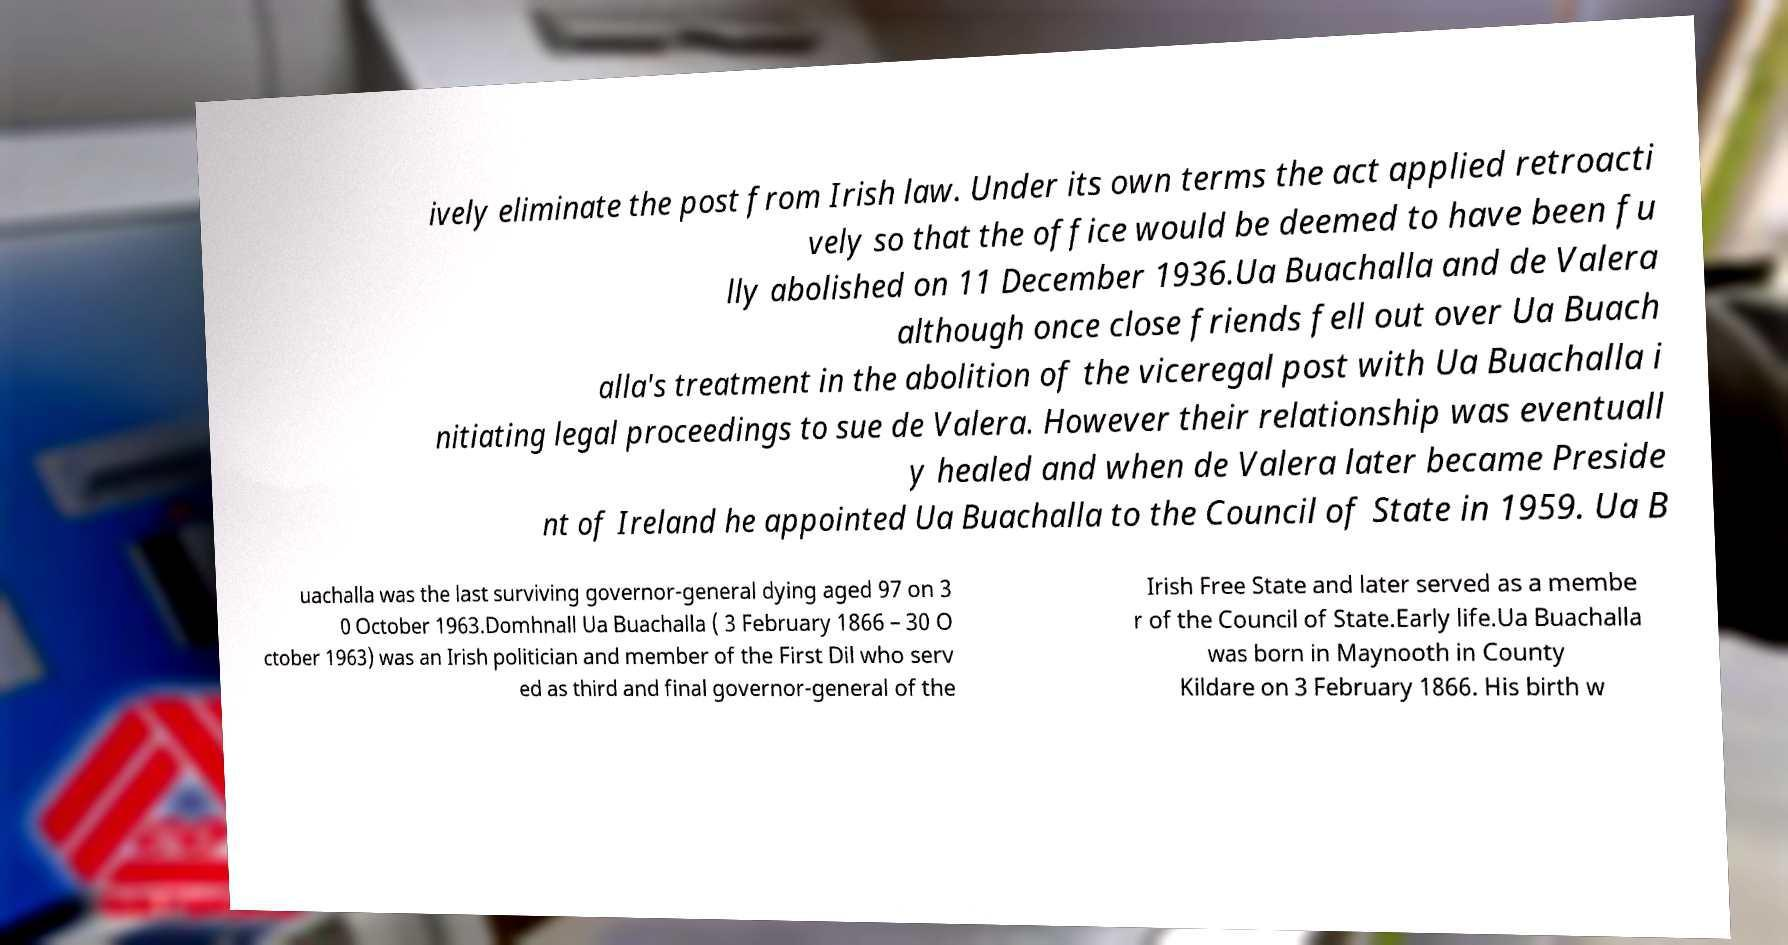Can you read and provide the text displayed in the image?This photo seems to have some interesting text. Can you extract and type it out for me? ively eliminate the post from Irish law. Under its own terms the act applied retroacti vely so that the office would be deemed to have been fu lly abolished on 11 December 1936.Ua Buachalla and de Valera although once close friends fell out over Ua Buach alla's treatment in the abolition of the viceregal post with Ua Buachalla i nitiating legal proceedings to sue de Valera. However their relationship was eventuall y healed and when de Valera later became Preside nt of Ireland he appointed Ua Buachalla to the Council of State in 1959. Ua B uachalla was the last surviving governor-general dying aged 97 on 3 0 October 1963.Domhnall Ua Buachalla ( 3 February 1866 – 30 O ctober 1963) was an Irish politician and member of the First Dil who serv ed as third and final governor-general of the Irish Free State and later served as a membe r of the Council of State.Early life.Ua Buachalla was born in Maynooth in County Kildare on 3 February 1866. His birth w 